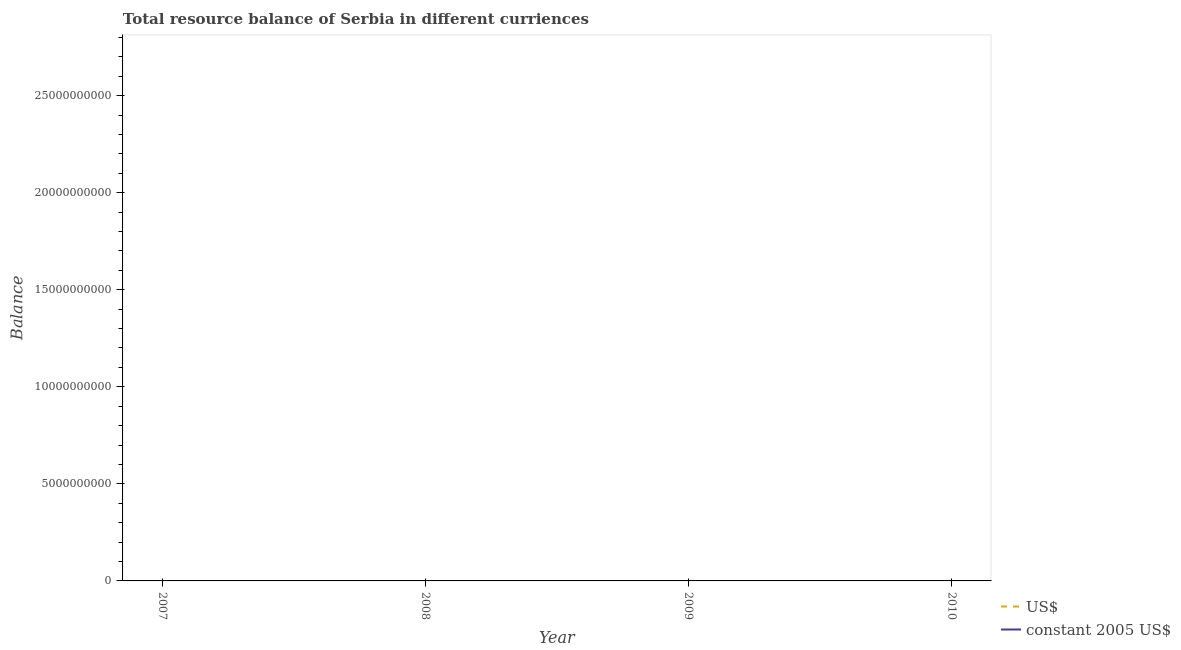Does the line corresponding to resource balance in constant us$ intersect with the line corresponding to resource balance in us$?
Your response must be concise. No. What is the resource balance in constant us$ in 2010?
Keep it short and to the point. 0. Across all years, what is the minimum resource balance in constant us$?
Ensure brevity in your answer.  0. What is the total resource balance in constant us$ in the graph?
Your response must be concise. 0. What is the difference between the resource balance in constant us$ in 2009 and the resource balance in us$ in 2008?
Give a very brief answer. 0. Does the resource balance in constant us$ monotonically increase over the years?
Offer a terse response. No. Is the resource balance in us$ strictly greater than the resource balance in constant us$ over the years?
Your response must be concise. Yes. Is the resource balance in us$ strictly less than the resource balance in constant us$ over the years?
Offer a terse response. No. How many years are there in the graph?
Your response must be concise. 4. What is the difference between two consecutive major ticks on the Y-axis?
Give a very brief answer. 5.00e+09. Does the graph contain grids?
Make the answer very short. No. How many legend labels are there?
Your answer should be very brief. 2. How are the legend labels stacked?
Provide a short and direct response. Vertical. What is the title of the graph?
Your response must be concise. Total resource balance of Serbia in different curriences. Does "Nitrous oxide emissions" appear as one of the legend labels in the graph?
Provide a succinct answer. No. What is the label or title of the X-axis?
Make the answer very short. Year. What is the label or title of the Y-axis?
Make the answer very short. Balance. What is the Balance of US$ in 2007?
Keep it short and to the point. 0. What is the Balance of constant 2005 US$ in 2007?
Make the answer very short. 0. What is the total Balance in US$ in the graph?
Offer a very short reply. 0. What is the average Balance in US$ per year?
Keep it short and to the point. 0. What is the average Balance in constant 2005 US$ per year?
Your answer should be very brief. 0. 